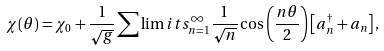<formula> <loc_0><loc_0><loc_500><loc_500>\chi ( \theta ) = \chi _ { 0 } + \frac { 1 } { \sqrt { g } } \sum \lim i t s _ { n = 1 } ^ { \infty } \frac { 1 } { \sqrt { n } } \cos { \left ( \frac { n \theta } { 2 } \right ) } \left [ a _ { n } ^ { \dagger } + a _ { n } \right ] ,</formula> 